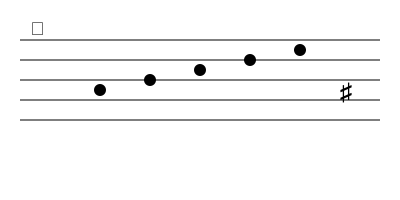In this excerpt from one of Beethoven's compositions, what is the name of the note on the fourth beat, and how would it be played on a piano? To answer this question, let's analyze the musical staff step-by-step:

1. The treble clef (𝄞) at the beginning indicates that this staff is for higher-pitched instruments or the right hand on a piano.

2. We can see five notes ascending the staff.

3. The fourth note (on the fourth beat) is positioned on the first line from the top of the staff.

4. In the treble clef, the lines from bottom to top represent E, G, B, D, and F.

5. Therefore, the note on the fourth beat is an F.

6. However, there is a sharp sign (♯) at the end of the staff, which applies to all F notes in this measure.

7. When an F is sharpened, it becomes F♯ (F-sharp).

8. On a piano, F♯ is played by pressing the black key immediately to the right of the white F key.

Thus, the note on the fourth beat is F♯, and it would be played on the black key between F and G on a piano.
Answer: F♯ (F-sharp), played on the black key between F and G. 